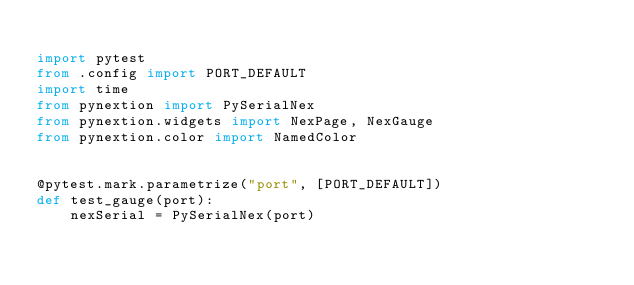Convert code to text. <code><loc_0><loc_0><loc_500><loc_500><_Python_>
import pytest
from .config import PORT_DEFAULT
import time
from pynextion import PySerialNex
from pynextion.widgets import NexPage, NexGauge
from pynextion.color import NamedColor


@pytest.mark.parametrize("port", [PORT_DEFAULT])
def test_gauge(port):
    nexSerial = PySerialNex(port)</code> 